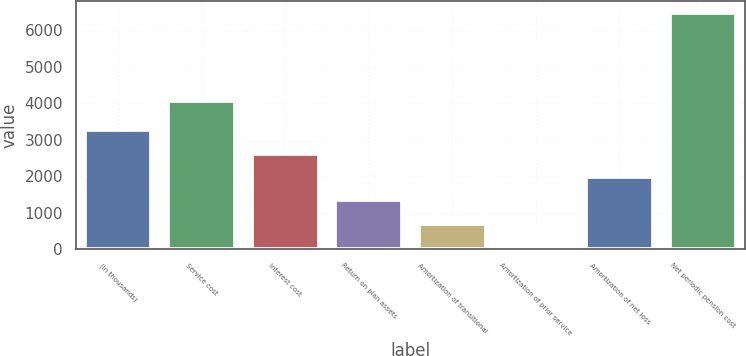Convert chart. <chart><loc_0><loc_0><loc_500><loc_500><bar_chart><fcel>(In thousands)<fcel>Service cost<fcel>Interest cost<fcel>Return on plan assets<fcel>Amortization of transitional<fcel>Amortization of prior service<fcel>Amortization of net loss<fcel>Net periodic pension cost<nl><fcel>3260.5<fcel>4054<fcel>2618.8<fcel>1335.4<fcel>693.7<fcel>52<fcel>1977.1<fcel>6469<nl></chart> 